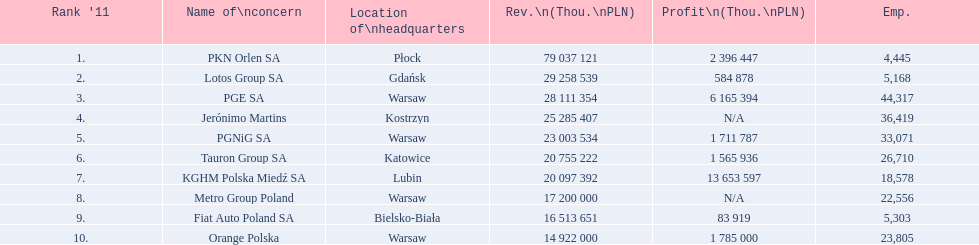What company has 28 111 354 thou.in revenue? PGE SA. What revenue does lotus group sa have? 29 258 539. Who has the next highest revenue than lotus group sa? PKN Orlen SA. 